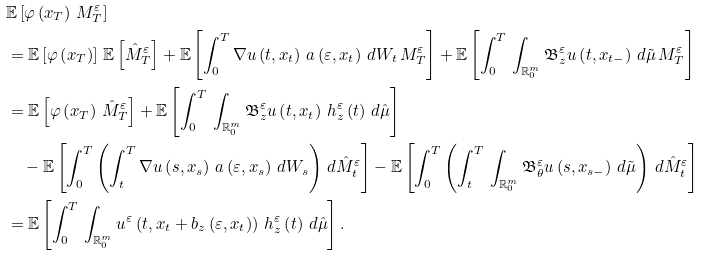Convert formula to latex. <formula><loc_0><loc_0><loc_500><loc_500>& \mathbb { E } \left [ \varphi \left ( x _ { T } \right ) \, M _ { T } ^ { \varepsilon } \right ] \\ & = \mathbb { E } \left [ \varphi \left ( x _ { T } \right ) \right ] \, \mathbb { E } \left [ \hat { M } _ { T } ^ { \varepsilon } \right ] + \mathbb { E } \left [ \int _ { 0 } ^ { T } \nabla u \left ( t , x _ { t } \right ) \, a \left ( \varepsilon , x _ { t } \right ) \, d W _ { t } \, M _ { T } ^ { \varepsilon } \right ] + \mathbb { E } \left [ \int _ { 0 } ^ { T } \, \int _ { \mathbb { R } _ { 0 } ^ { m } } \mathfrak { B } _ { z } ^ { \varepsilon } u \left ( t , x _ { t - } \right ) \, d \tilde { \mu } \, M _ { T } ^ { \varepsilon } \right ] \\ & = \mathbb { E } \left [ \varphi \left ( x _ { T } \right ) \, \hat { M } _ { T } ^ { \varepsilon } \right ] + \mathbb { E } \left [ \int _ { 0 } ^ { T } \, \int _ { \mathbb { R } _ { 0 } ^ { m } } \mathfrak { B } _ { z } ^ { \varepsilon } u \left ( t , x _ { t } \right ) \, h _ { z } ^ { \varepsilon } \left ( t \right ) \, d \hat { \mu } \right ] \\ & \quad - \mathbb { E } \left [ \int _ { 0 } ^ { T } \left ( \int _ { t } ^ { T } \nabla u \left ( s , x _ { s } \right ) \, a \left ( \varepsilon , x _ { s } \right ) \, d W _ { s } \right ) \, d \hat { M } _ { t } ^ { \varepsilon } \right ] - \mathbb { E } \left [ \int _ { 0 } ^ { T } \left ( \int _ { t } ^ { T } \, \int _ { \mathbb { R } _ { 0 } ^ { m } } \mathfrak { B } _ { \theta } ^ { \varepsilon } u \left ( s , x _ { s - } \right ) \, d \tilde { \mu } \right ) \, d \hat { M } _ { t } ^ { \varepsilon } \right ] \\ & = \mathbb { E } \left [ \int _ { 0 } ^ { T } \, \int _ { \mathbb { R } _ { 0 } ^ { m } } u ^ { \varepsilon } \left ( t , x _ { t } + b _ { z } \left ( \varepsilon , x _ { t } \right ) \right ) \, h _ { z } ^ { \varepsilon } \left ( t \right ) \, d \hat { \mu } \right ] .</formula> 